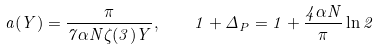Convert formula to latex. <formula><loc_0><loc_0><loc_500><loc_500>a ( Y ) = \frac { \pi } { 7 \alpha N \zeta ( 3 ) Y } , \quad 1 + \Delta _ { P } = 1 + \frac { 4 \alpha N } { \pi } \ln 2</formula> 